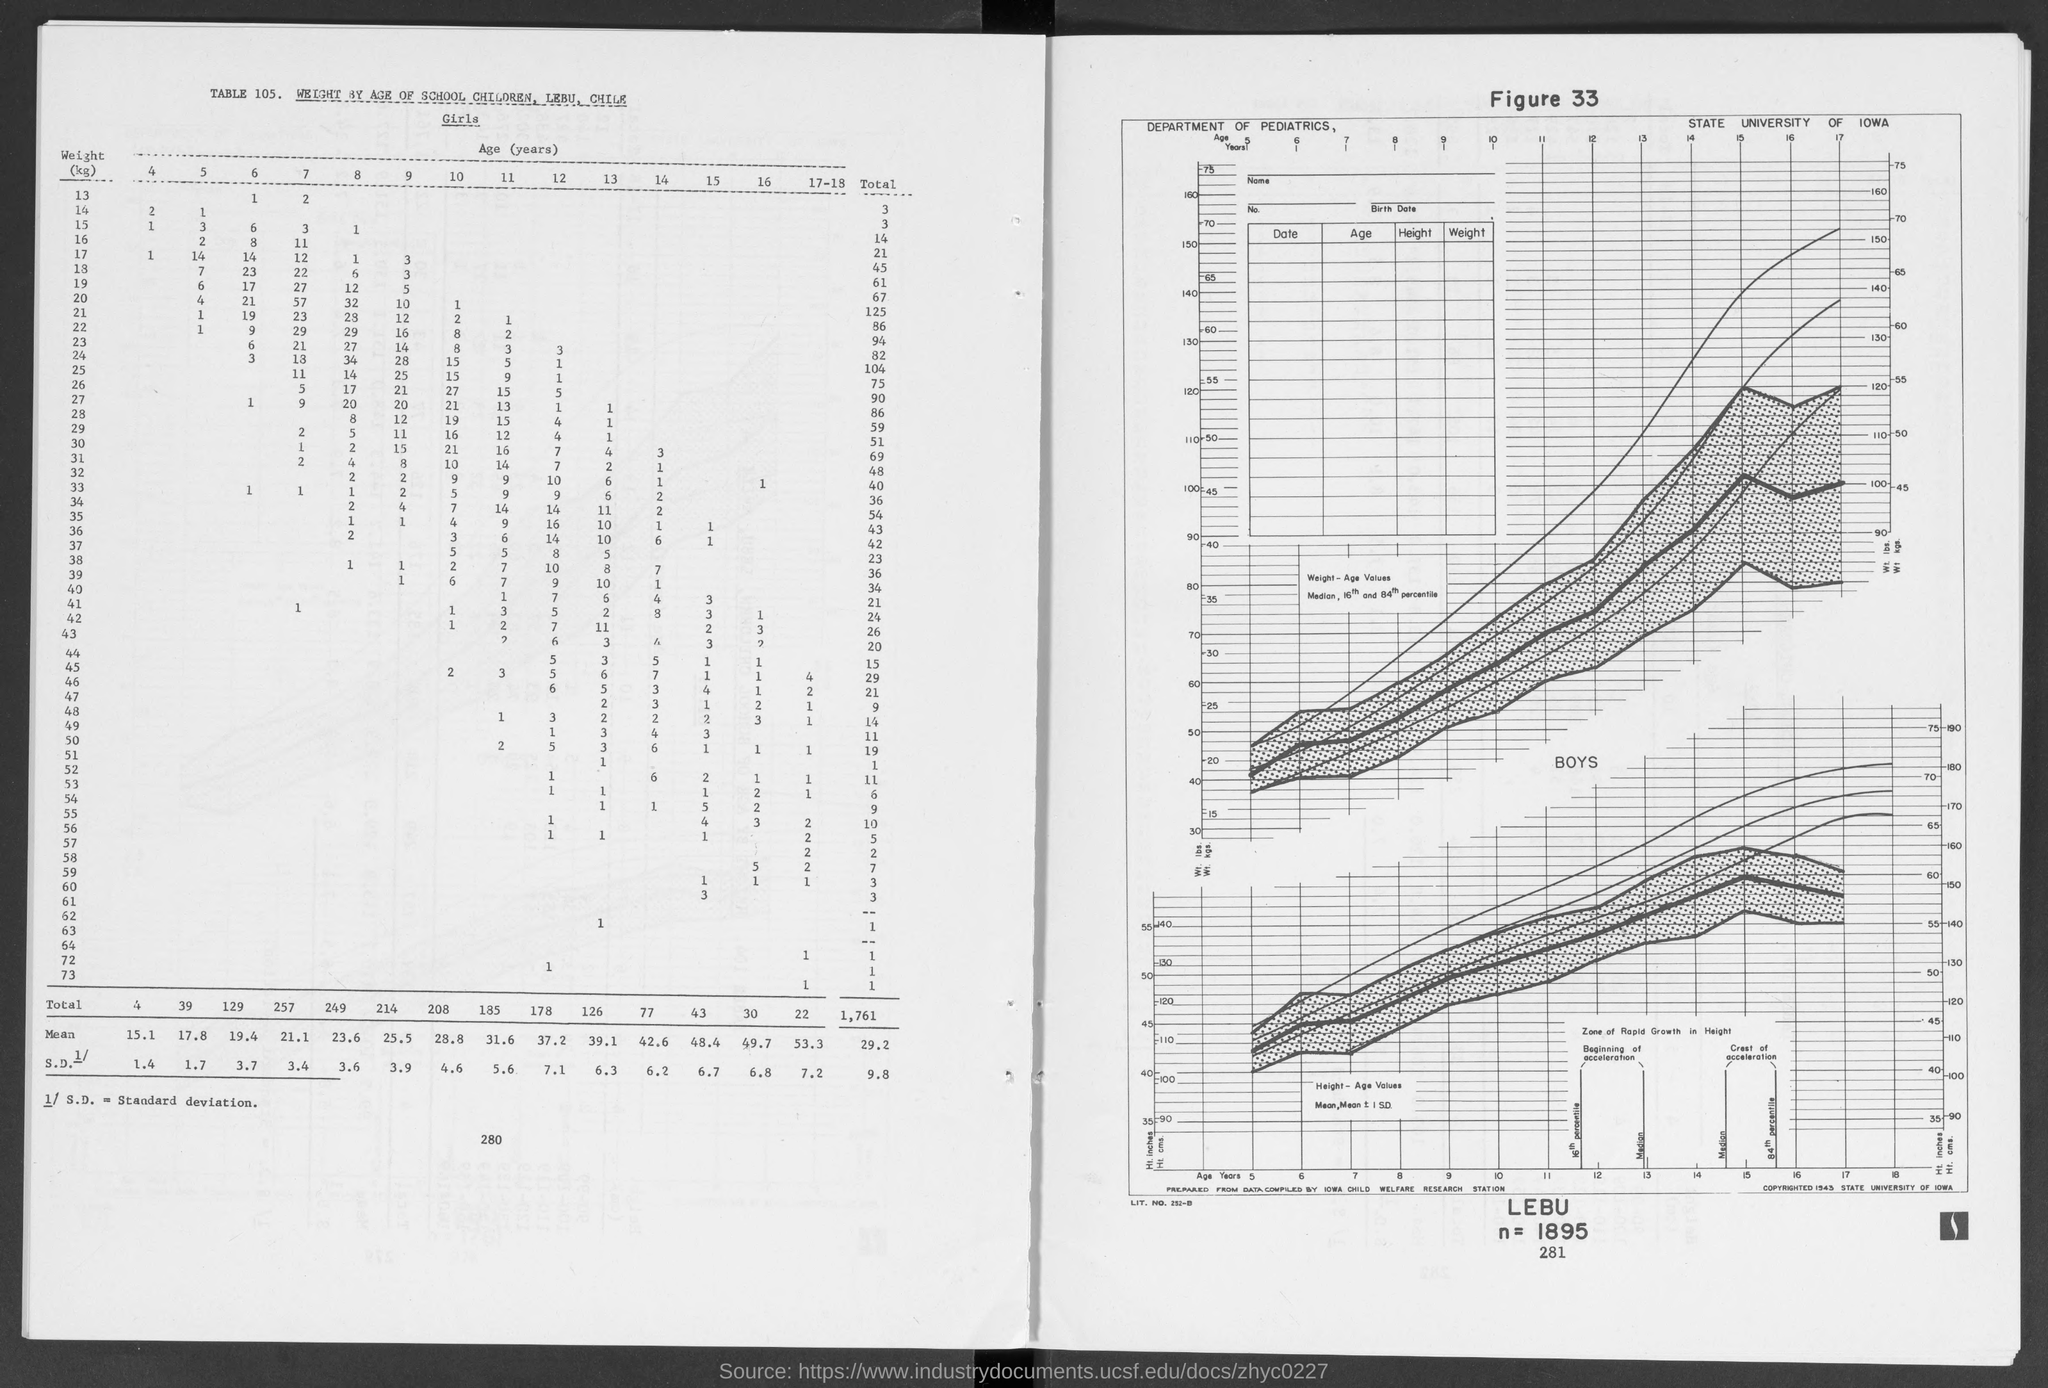Draw attention to some important aspects in this diagram. The total number of girls weighing 13 kilograms is 3. It is unknown what the total number of girls of weight 15, 14, or any other specific weight is. The number of girls with a weight of 13 and an age of 7 is 2. The value of n is 1895. The figure number is 33. 